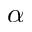<formula> <loc_0><loc_0><loc_500><loc_500>\alpha</formula> 